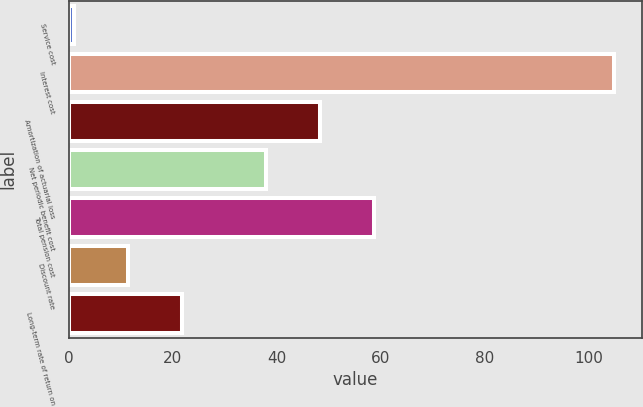Convert chart to OTSL. <chart><loc_0><loc_0><loc_500><loc_500><bar_chart><fcel>Service cost<fcel>Interest cost<fcel>Amortization of actuarial loss<fcel>Net periodic benefit cost<fcel>Total pension cost<fcel>Discount rate<fcel>Long-term rate of return on<nl><fcel>1<fcel>105<fcel>48.4<fcel>38<fcel>58.8<fcel>11.4<fcel>21.8<nl></chart> 